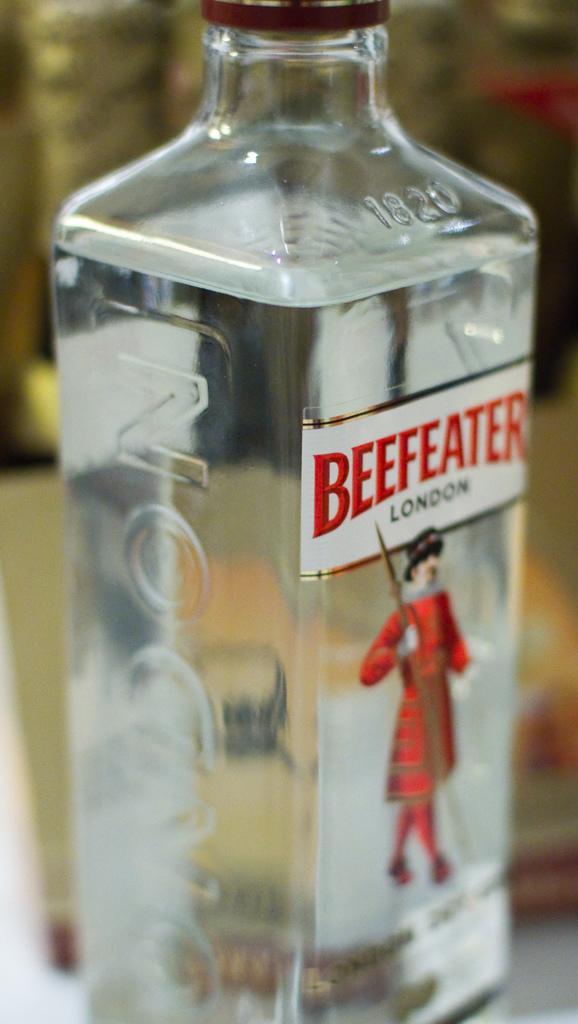In one or two sentences, can you explain what this image depicts? In the image we can see there is a beer bottle and on it statue of a man who is standing and holding a sword in his hand. 